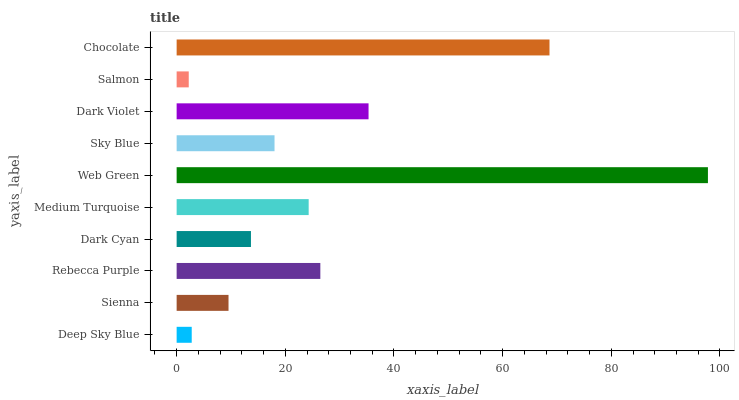Is Salmon the minimum?
Answer yes or no. Yes. Is Web Green the maximum?
Answer yes or no. Yes. Is Sienna the minimum?
Answer yes or no. No. Is Sienna the maximum?
Answer yes or no. No. Is Sienna greater than Deep Sky Blue?
Answer yes or no. Yes. Is Deep Sky Blue less than Sienna?
Answer yes or no. Yes. Is Deep Sky Blue greater than Sienna?
Answer yes or no. No. Is Sienna less than Deep Sky Blue?
Answer yes or no. No. Is Medium Turquoise the high median?
Answer yes or no. Yes. Is Sky Blue the low median?
Answer yes or no. Yes. Is Deep Sky Blue the high median?
Answer yes or no. No. Is Rebecca Purple the low median?
Answer yes or no. No. 